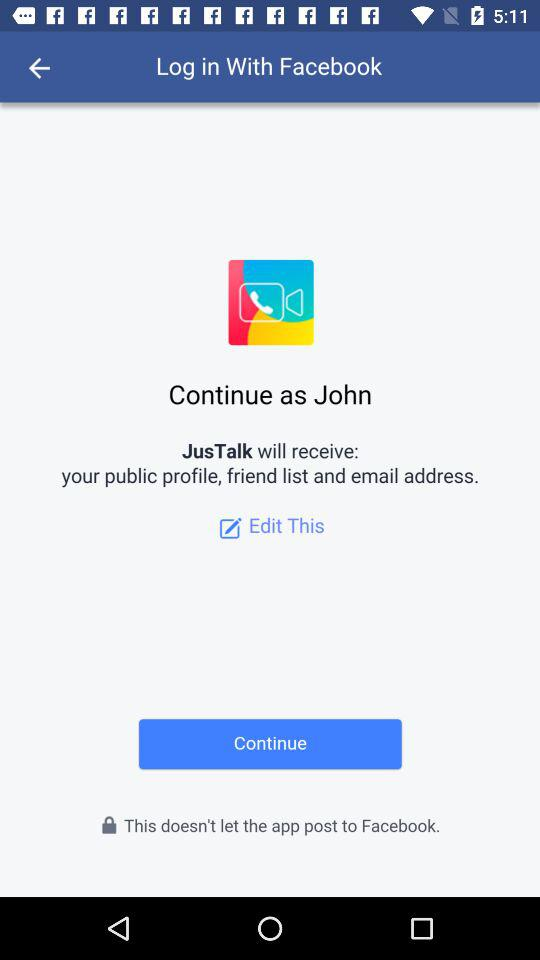How many items does JusTalk receive?
Answer the question using a single word or phrase. 3 